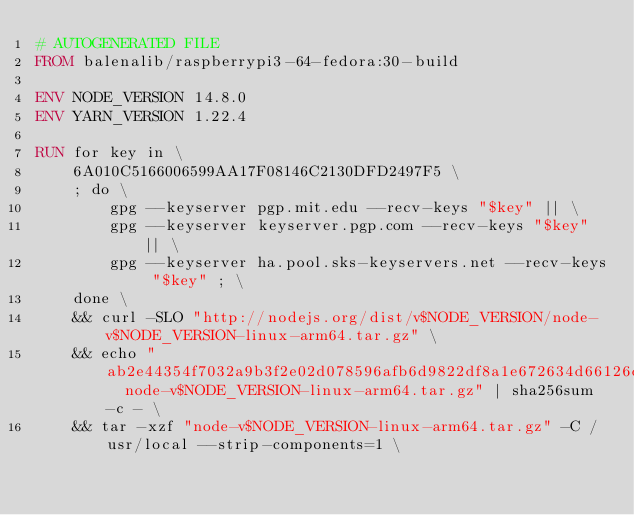<code> <loc_0><loc_0><loc_500><loc_500><_Dockerfile_># AUTOGENERATED FILE
FROM balenalib/raspberrypi3-64-fedora:30-build

ENV NODE_VERSION 14.8.0
ENV YARN_VERSION 1.22.4

RUN for key in \
	6A010C5166006599AA17F08146C2130DFD2497F5 \
	; do \
		gpg --keyserver pgp.mit.edu --recv-keys "$key" || \
		gpg --keyserver keyserver.pgp.com --recv-keys "$key" || \
		gpg --keyserver ha.pool.sks-keyservers.net --recv-keys "$key" ; \
	done \
	&& curl -SLO "http://nodejs.org/dist/v$NODE_VERSION/node-v$NODE_VERSION-linux-arm64.tar.gz" \
	&& echo "ab2e44354f7032a9b3f2e02d078596afb6d9822df8a1e672634d66126d17df7a  node-v$NODE_VERSION-linux-arm64.tar.gz" | sha256sum -c - \
	&& tar -xzf "node-v$NODE_VERSION-linux-arm64.tar.gz" -C /usr/local --strip-components=1 \</code> 